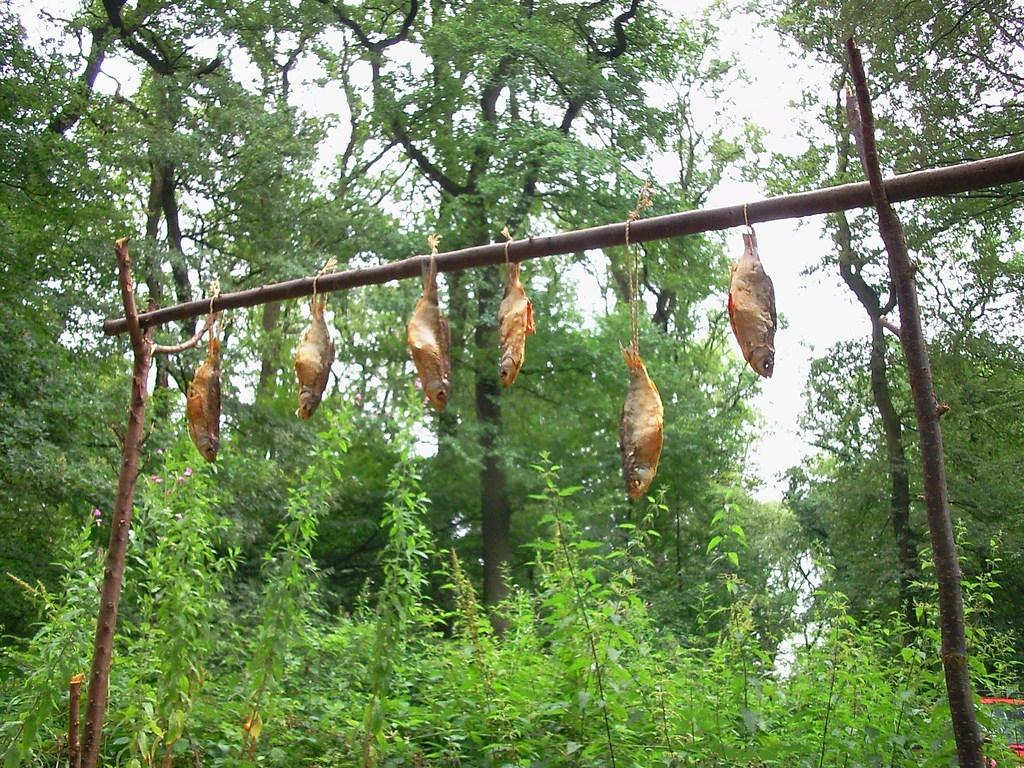What is hanging on the stick in the image? There are fishes hanging on a stick in the image. What can be seen in the background of the image? There are trees visible in the background of the image. What is visible at the top of the image? The sky is visible at the top of the image. What type of vegetation is present at the bottom of the image? Plants are present at the bottom of the image. Where is the pocket located in the image? There is no pocket present in the image. What type of punishment is being depicted in the image? There is no punishment being depicted in the image; it features fishes hanging on a stick with trees, sky, and plants in the background. 